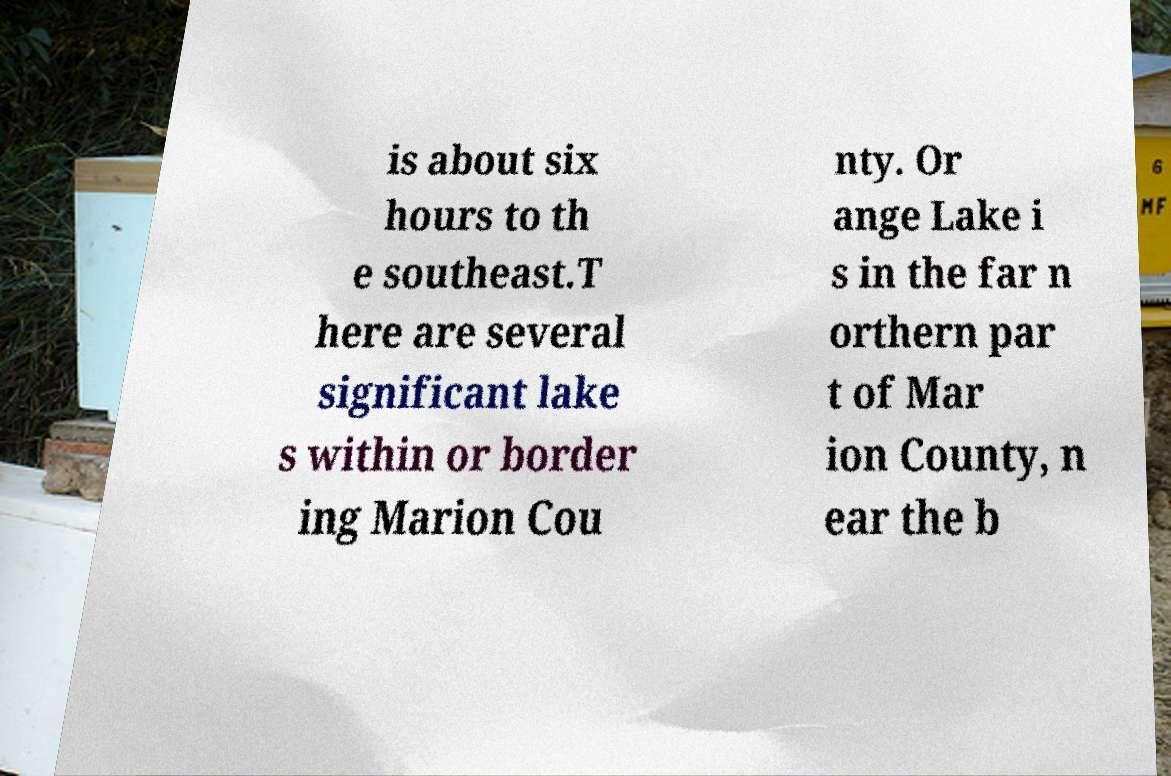I need the written content from this picture converted into text. Can you do that? is about six hours to th e southeast.T here are several significant lake s within or border ing Marion Cou nty. Or ange Lake i s in the far n orthern par t of Mar ion County, n ear the b 